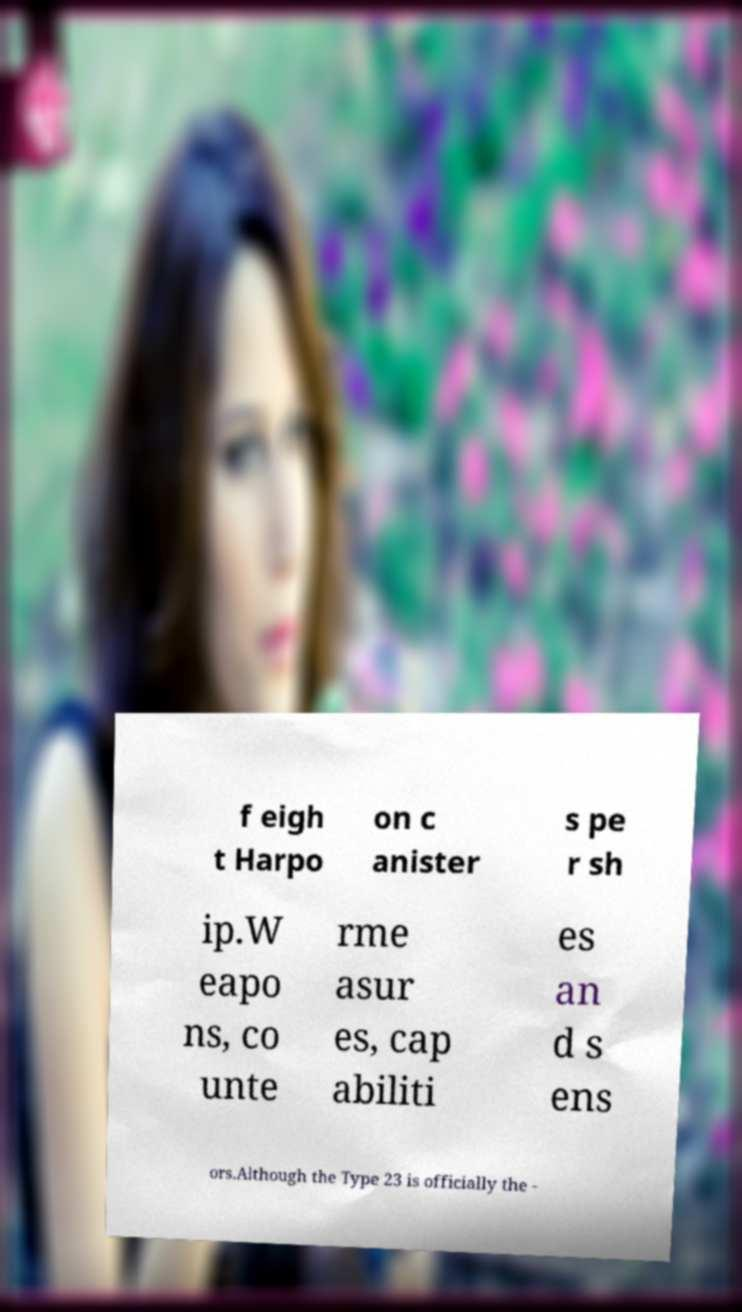Could you extract and type out the text from this image? f eigh t Harpo on c anister s pe r sh ip.W eapo ns, co unte rme asur es, cap abiliti es an d s ens ors.Although the Type 23 is officially the - 